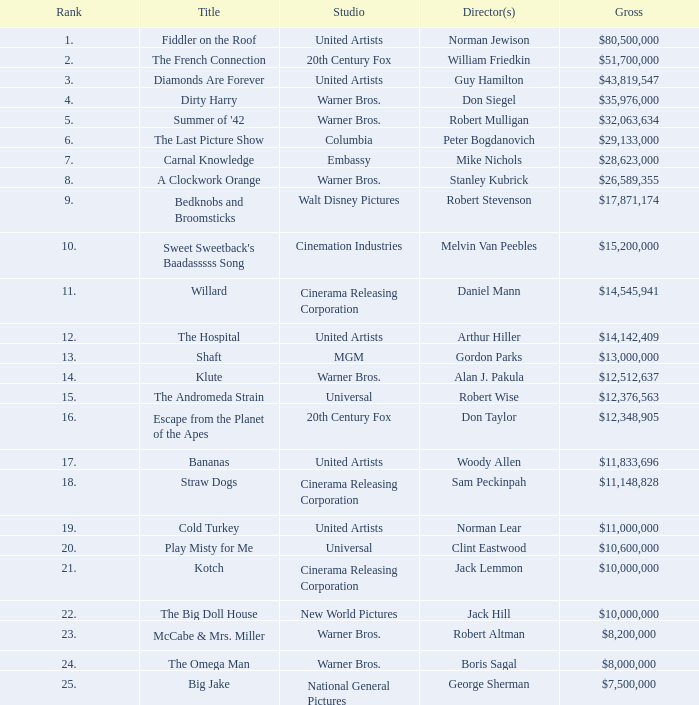What is the title's rank with earnings amounting to $26,589,355? 8.0. 